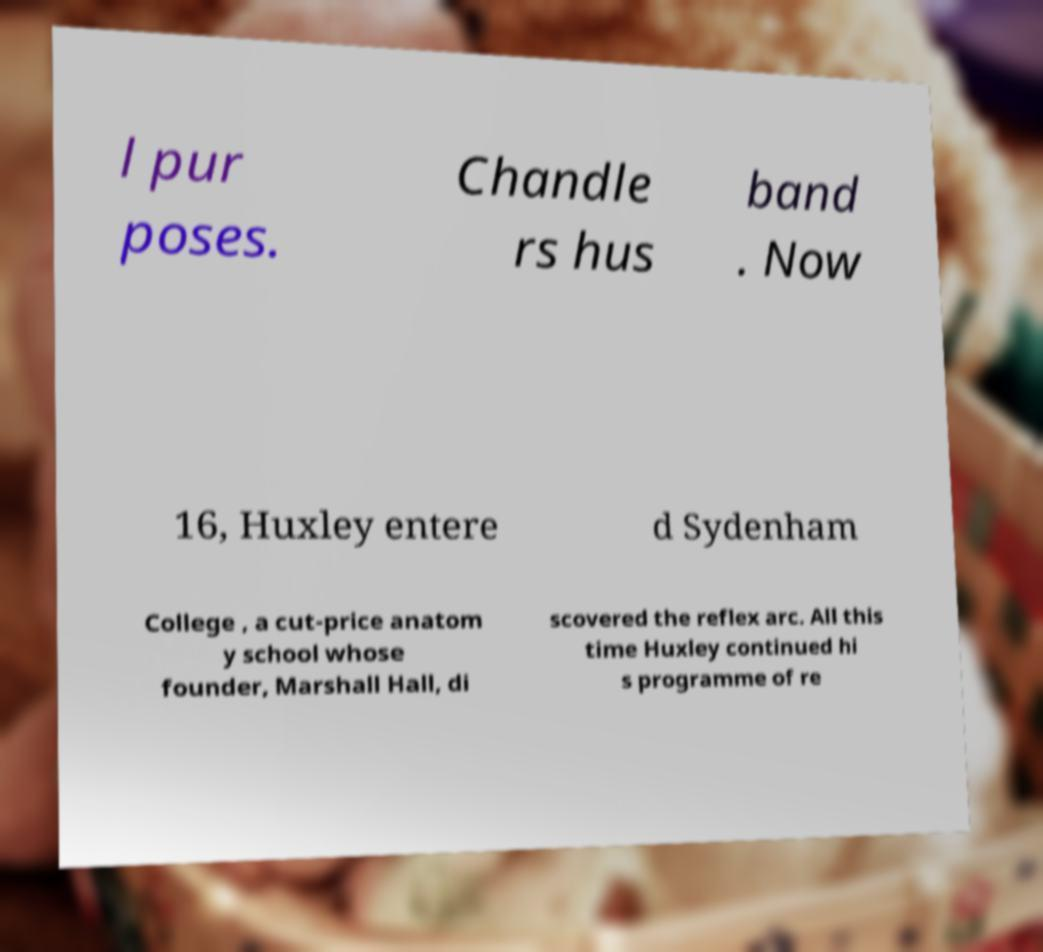Can you accurately transcribe the text from the provided image for me? l pur poses. Chandle rs hus band . Now 16, Huxley entere d Sydenham College , a cut-price anatom y school whose founder, Marshall Hall, di scovered the reflex arc. All this time Huxley continued hi s programme of re 